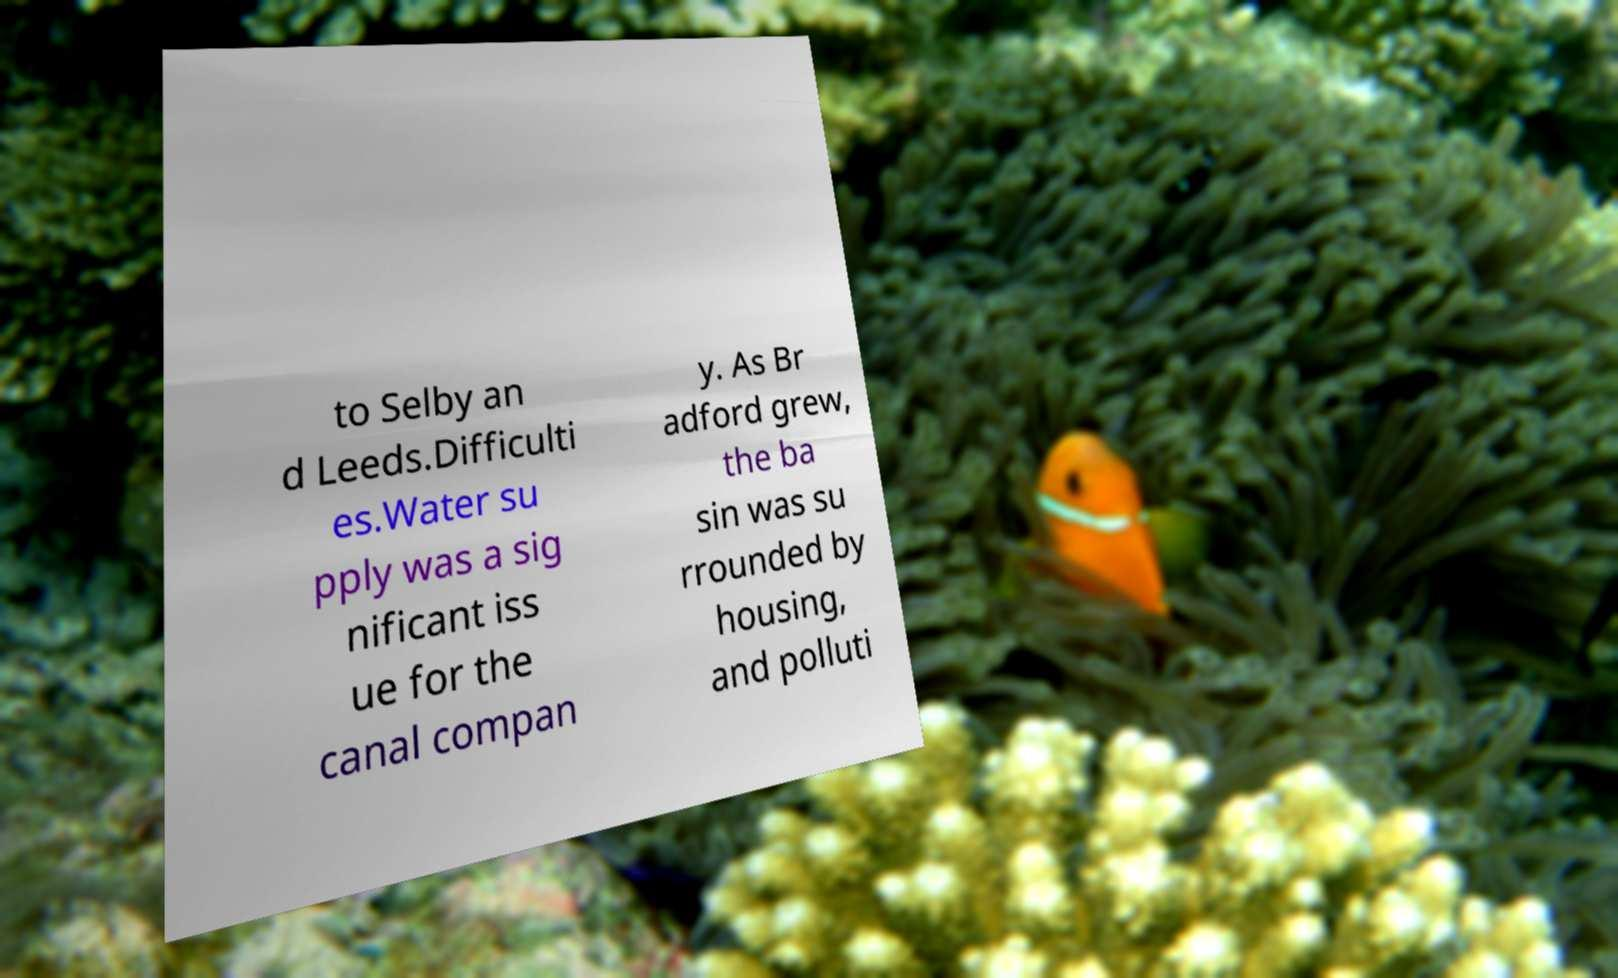Could you extract and type out the text from this image? to Selby an d Leeds.Difficulti es.Water su pply was a sig nificant iss ue for the canal compan y. As Br adford grew, the ba sin was su rrounded by housing, and polluti 